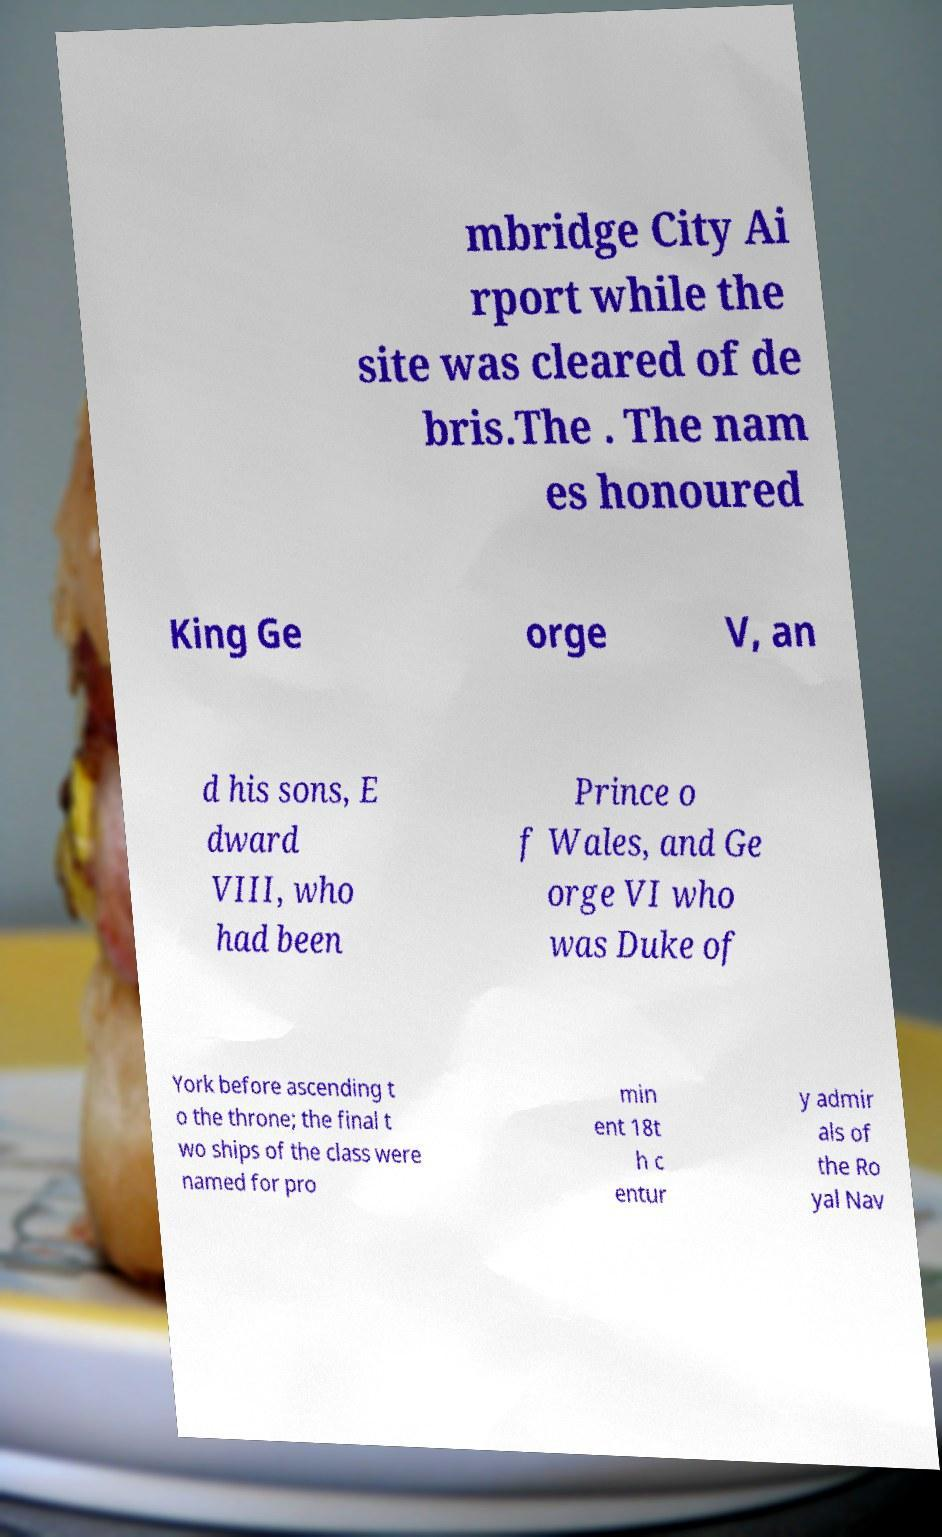Could you assist in decoding the text presented in this image and type it out clearly? mbridge City Ai rport while the site was cleared of de bris.The . The nam es honoured King Ge orge V, an d his sons, E dward VIII, who had been Prince o f Wales, and Ge orge VI who was Duke of York before ascending t o the throne; the final t wo ships of the class were named for pro min ent 18t h c entur y admir als of the Ro yal Nav 